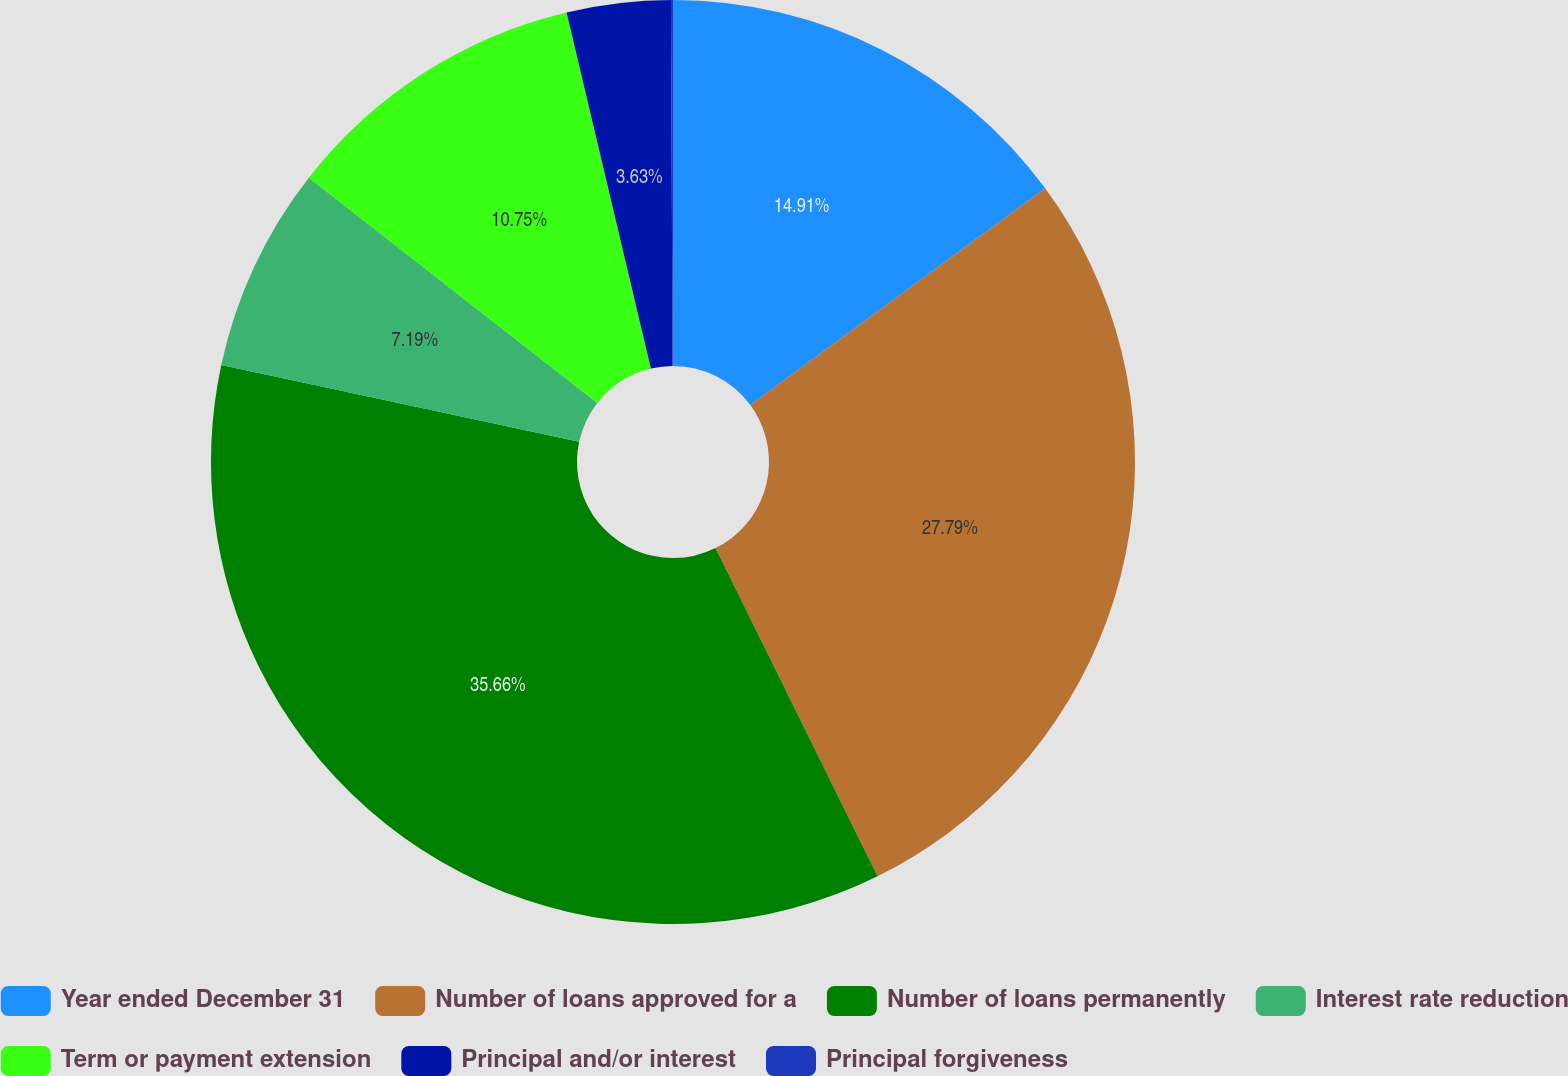Convert chart. <chart><loc_0><loc_0><loc_500><loc_500><pie_chart><fcel>Year ended December 31<fcel>Number of loans approved for a<fcel>Number of loans permanently<fcel>Interest rate reduction<fcel>Term or payment extension<fcel>Principal and/or interest<fcel>Principal forgiveness<nl><fcel>14.91%<fcel>27.8%<fcel>35.67%<fcel>7.19%<fcel>10.75%<fcel>3.63%<fcel>0.07%<nl></chart> 